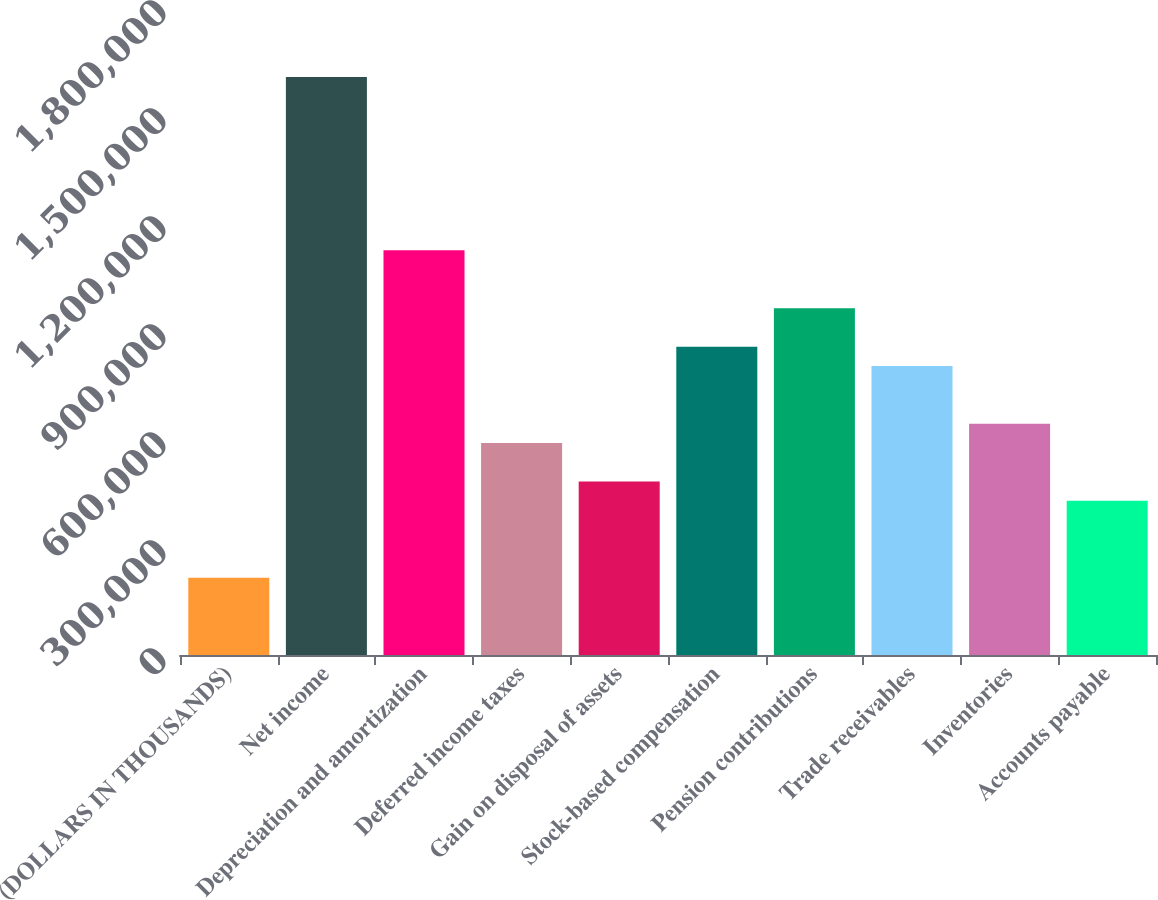Convert chart. <chart><loc_0><loc_0><loc_500><loc_500><bar_chart><fcel>(DOLLARS IN THOUSANDS)<fcel>Net income<fcel>Depreciation and amortization<fcel>Deferred income taxes<fcel>Gain on disposal of assets<fcel>Stock-based compensation<fcel>Pension contributions<fcel>Trade receivables<fcel>Inventories<fcel>Accounts payable<nl><fcel>214338<fcel>1.60563e+06<fcel>1.12403e+06<fcel>588917<fcel>481895<fcel>856474<fcel>963497<fcel>802963<fcel>642429<fcel>428383<nl></chart> 